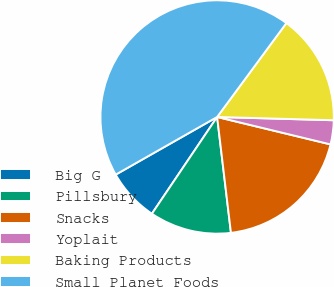Convert chart to OTSL. <chart><loc_0><loc_0><loc_500><loc_500><pie_chart><fcel>Big G<fcel>Pillsbury<fcel>Snacks<fcel>Yoplait<fcel>Baking Products<fcel>Small Planet Foods<nl><fcel>7.33%<fcel>11.33%<fcel>19.33%<fcel>3.33%<fcel>15.33%<fcel>43.33%<nl></chart> 